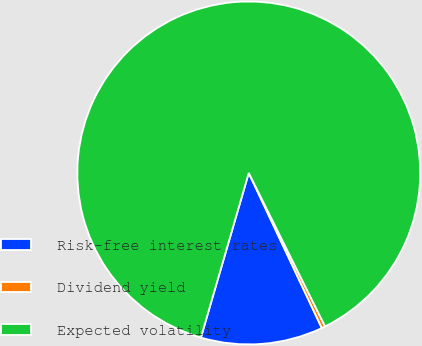Convert chart. <chart><loc_0><loc_0><loc_500><loc_500><pie_chart><fcel>Risk-free interest rates<fcel>Dividend yield<fcel>Expected volatility<nl><fcel>11.51%<fcel>0.34%<fcel>88.15%<nl></chart> 